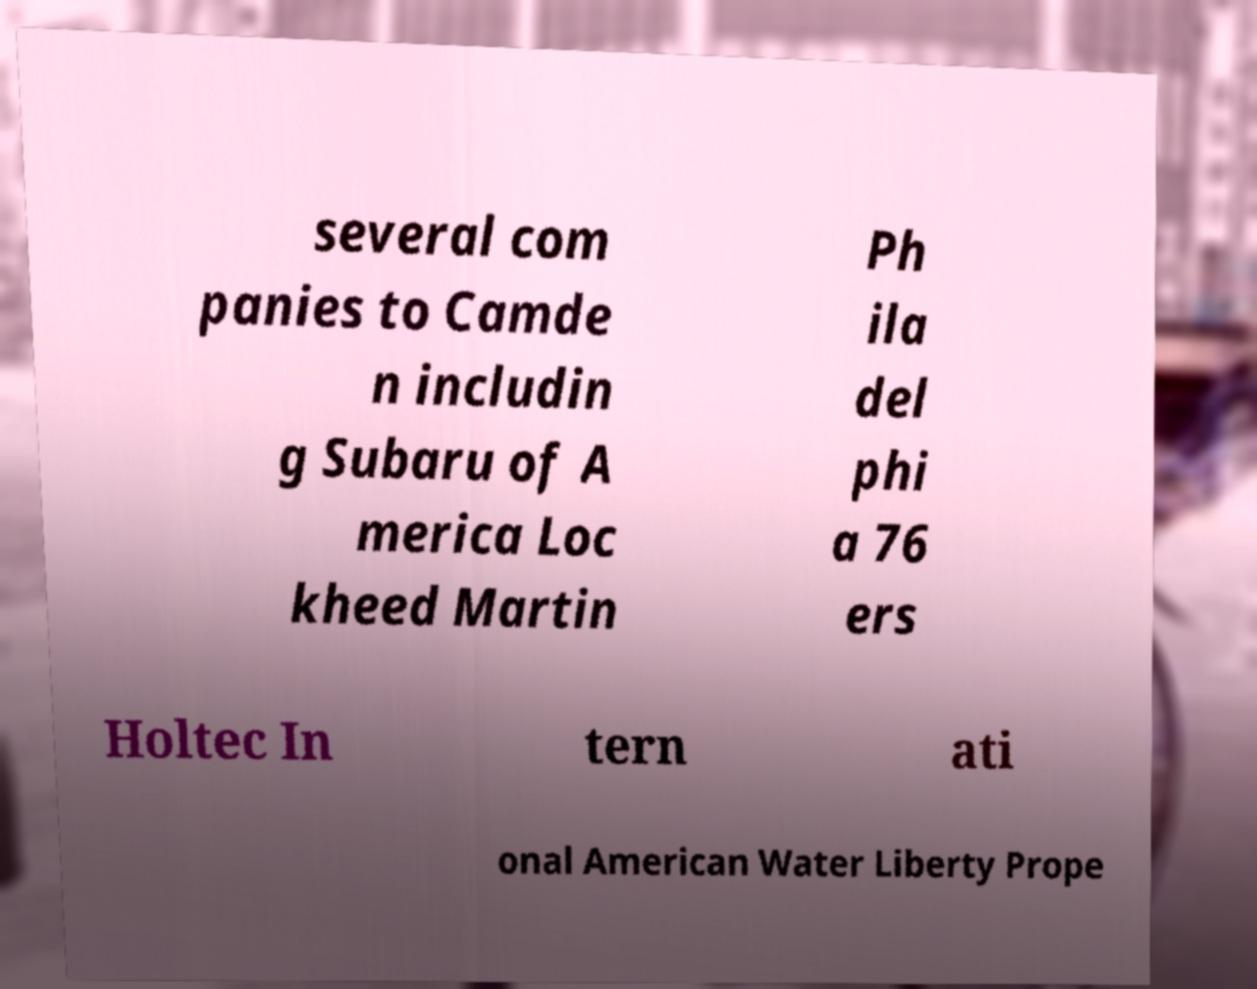Please identify and transcribe the text found in this image. several com panies to Camde n includin g Subaru of A merica Loc kheed Martin Ph ila del phi a 76 ers Holtec In tern ati onal American Water Liberty Prope 